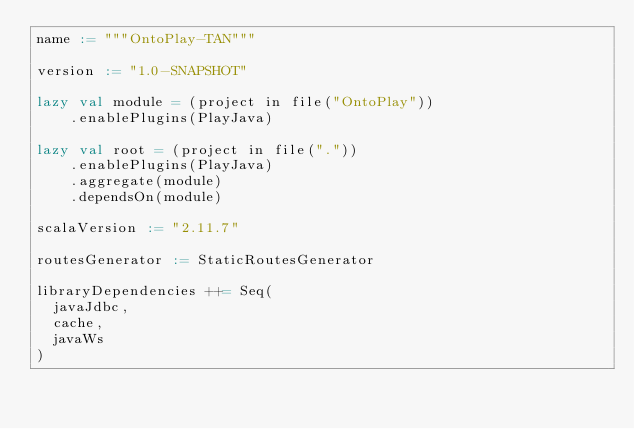<code> <loc_0><loc_0><loc_500><loc_500><_Scala_>name := """OntoPlay-TAN"""

version := "1.0-SNAPSHOT"

lazy val module = (project in file("OntoPlay"))
    .enablePlugins(PlayJava)

lazy val root = (project in file("."))
	.enablePlugins(PlayJava)
	.aggregate(module)
    .dependsOn(module)

scalaVersion := "2.11.7"

routesGenerator := StaticRoutesGenerator

libraryDependencies ++= Seq(
  javaJdbc,
  cache,
  javaWs
)
</code> 